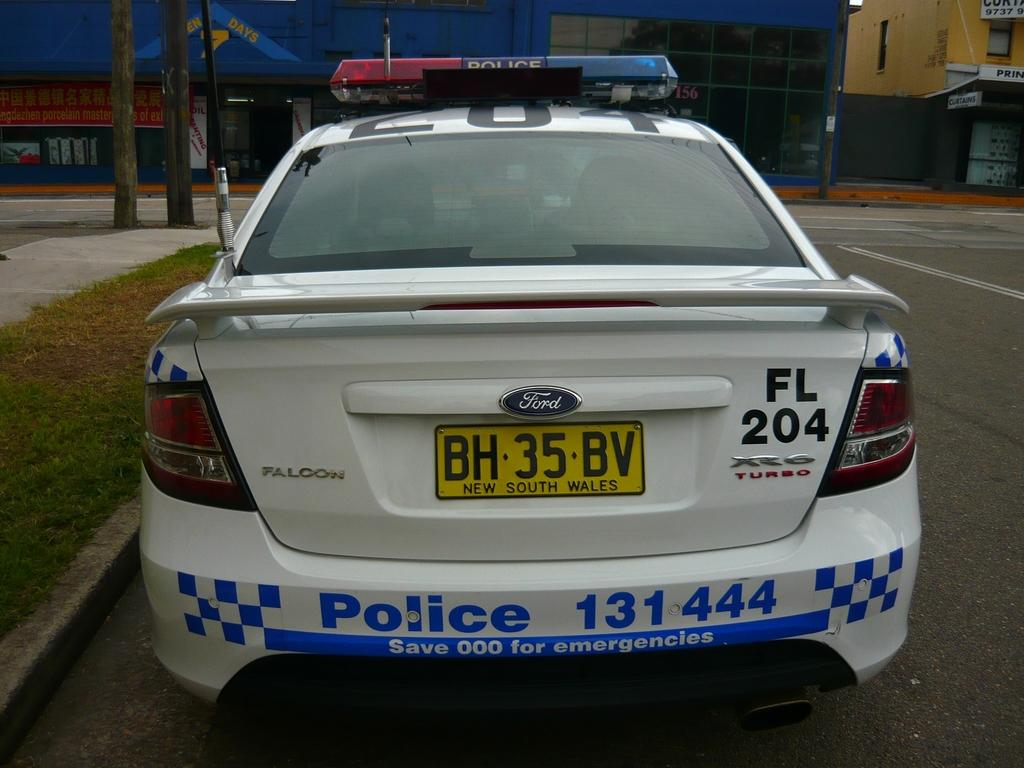What type of vehicle is present in the image? There is a police vehicle in the image. Where is the police vehicle located? The police vehicle is parked on the road. What type of vegetation can be seen in the image? There is grass visible in the image. What structures can be seen in the image? There are poles and buildings in the image. What part of a tree is visible in the image? The barks of trees are visible in the image. What time of day is it in the image, and what is the police officer doing in the afternoon? The provided facts do not mention the time of day or any police officer's actions, so we cannot determine the time or the officer's activities. 